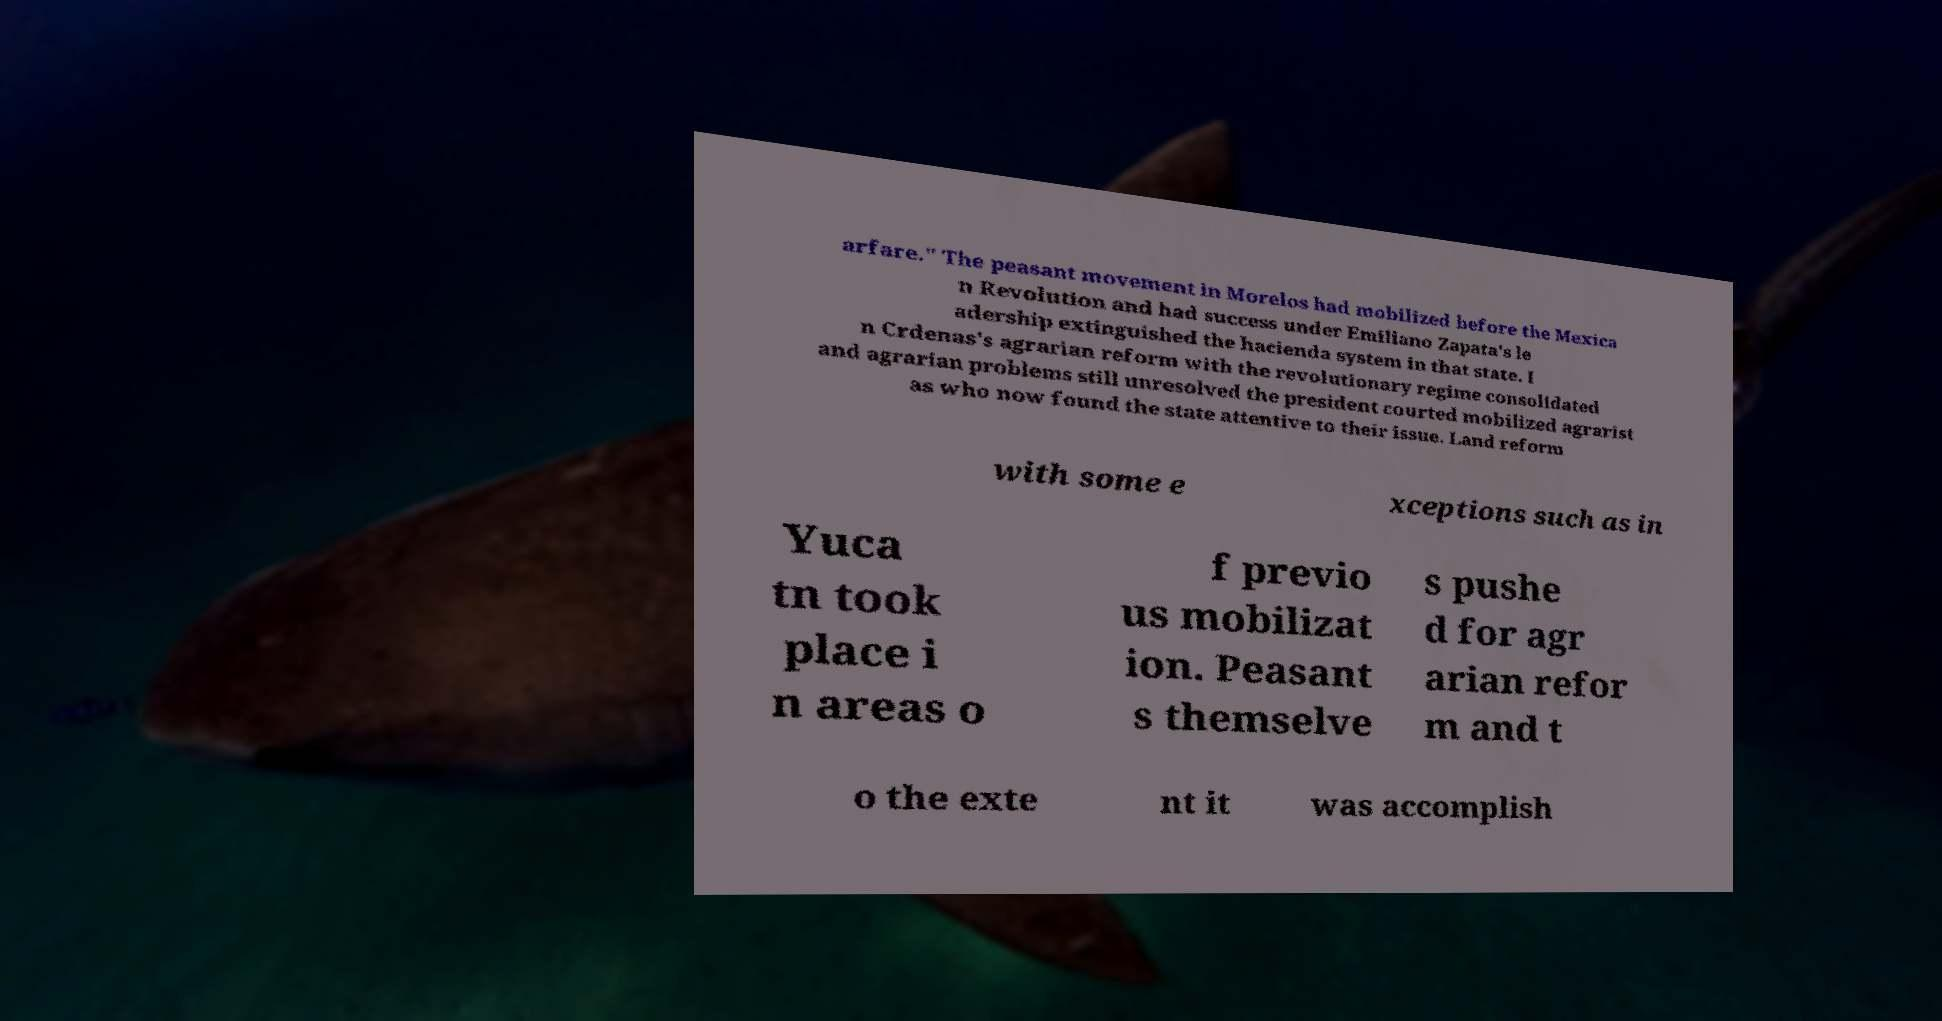Please read and relay the text visible in this image. What does it say? arfare." The peasant movement in Morelos had mobilized before the Mexica n Revolution and had success under Emiliano Zapata's le adership extinguished the hacienda system in that state. I n Crdenas's agrarian reform with the revolutionary regime consolidated and agrarian problems still unresolved the president courted mobilized agrarist as who now found the state attentive to their issue. Land reform with some e xceptions such as in Yuca tn took place i n areas o f previo us mobilizat ion. Peasant s themselve s pushe d for agr arian refor m and t o the exte nt it was accomplish 